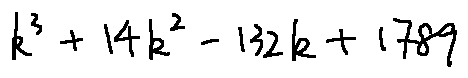Convert formula to latex. <formula><loc_0><loc_0><loc_500><loc_500>k ^ { 3 } + 1 4 k ^ { 2 } - 1 3 2 k + 1 7 8 9</formula> 